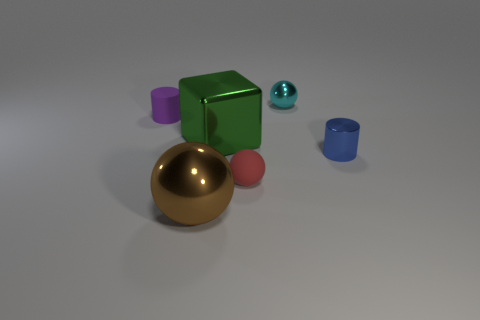Are there the same number of small red spheres that are behind the large green cube and small yellow metal cylinders?
Make the answer very short. Yes. What material is the tiny sphere that is in front of the shiny sphere behind the tiny ball in front of the metal block made of?
Provide a succinct answer. Rubber. There is a tiny blue object that is made of the same material as the big green block; what is its shape?
Your answer should be very brief. Cylinder. Is there any other thing that is the same color as the metallic cylinder?
Ensure brevity in your answer.  No. How many tiny things are in front of the small rubber thing that is right of the big object that is in front of the big green shiny object?
Make the answer very short. 0. How many brown things are either tiny metallic balls or large things?
Your response must be concise. 1. Is the size of the brown metallic thing the same as the cylinder that is behind the large metallic block?
Provide a short and direct response. No. What is the material of the tiny red thing that is the same shape as the large brown metallic thing?
Provide a short and direct response. Rubber. How many other objects are the same size as the matte cylinder?
Your answer should be compact. 3. The small metal thing in front of the small ball that is behind the rubber thing to the right of the large brown shiny ball is what shape?
Make the answer very short. Cylinder. 